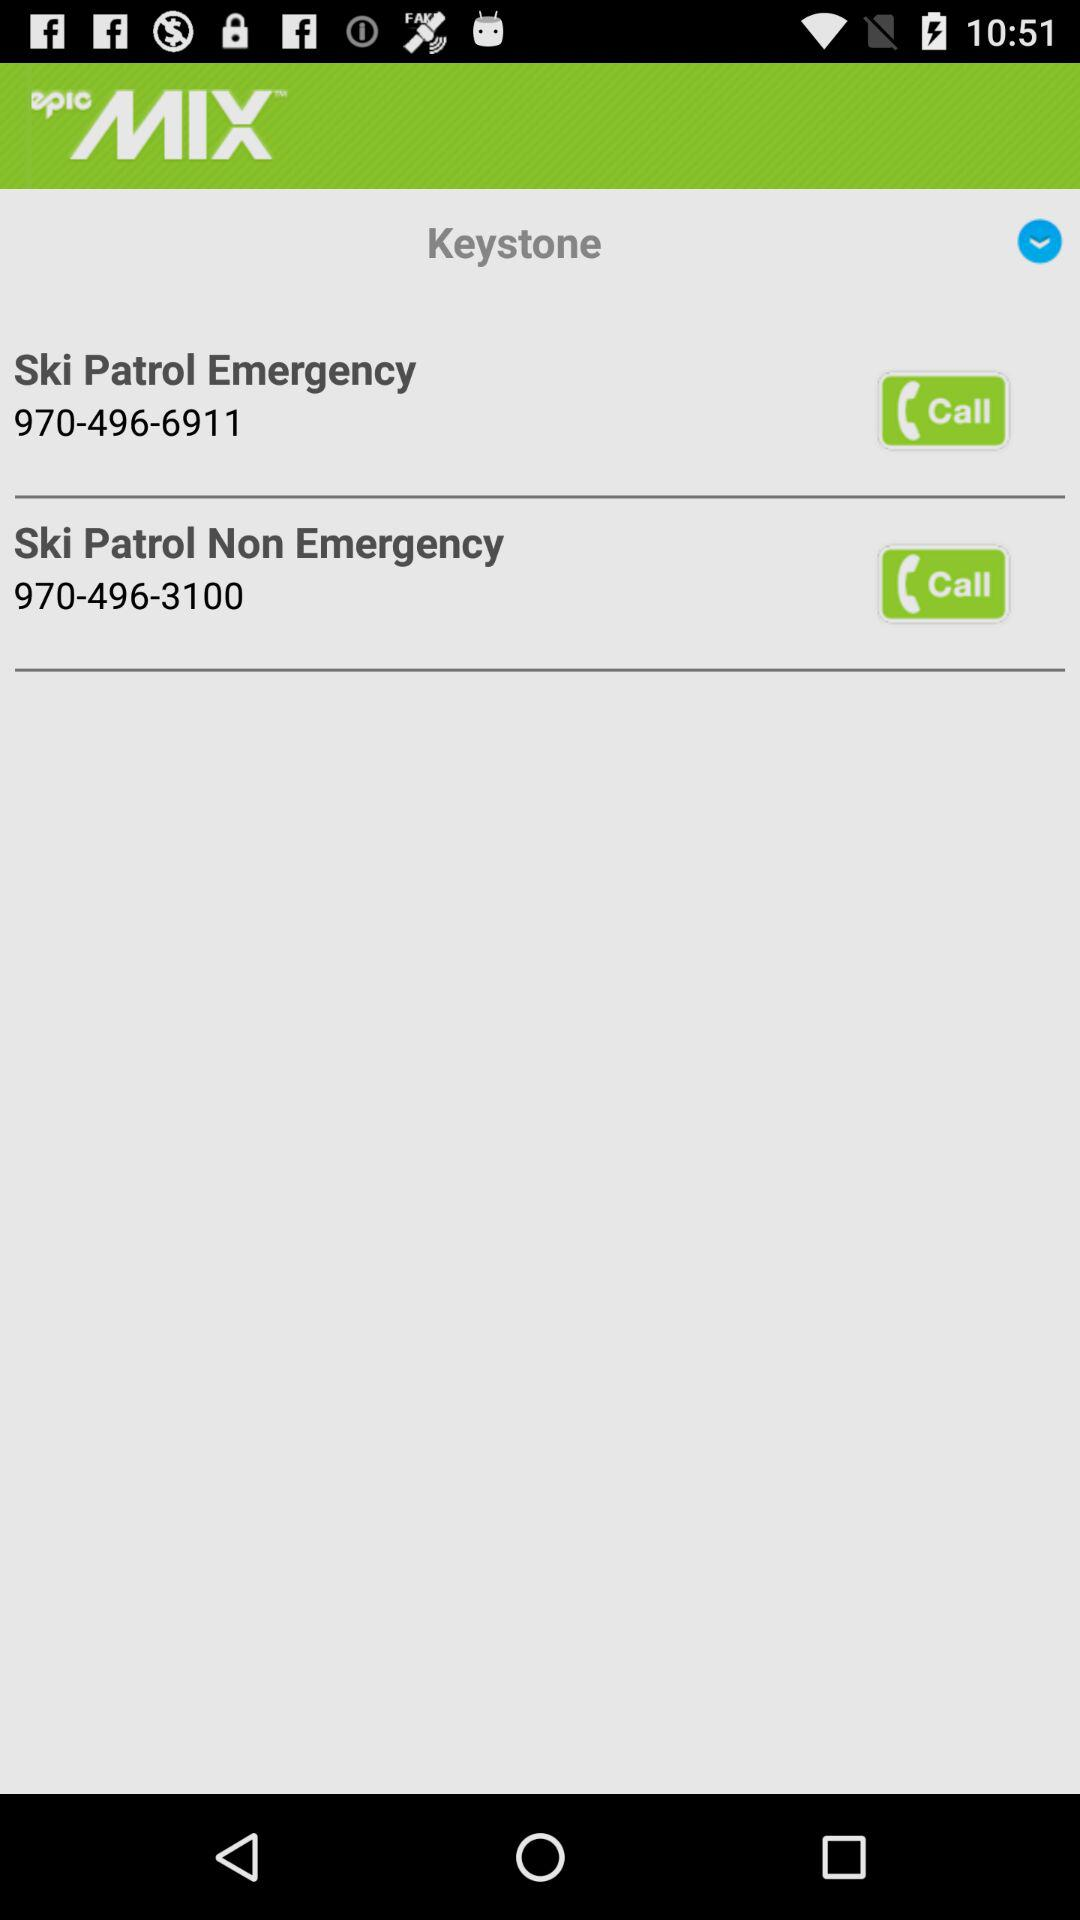What is the non emergency contact number for ski patrol? The non emergency contact number is 970-496-3100. 